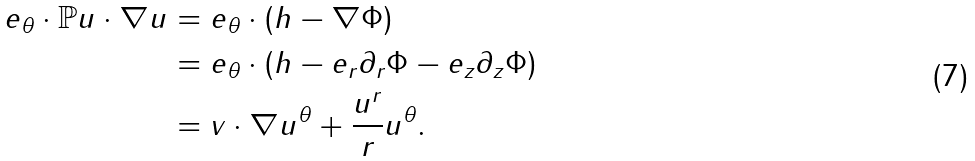<formula> <loc_0><loc_0><loc_500><loc_500>e _ { \theta } \cdot \mathbb { P } u \cdot \nabla u & = e _ { \theta } \cdot ( h - \nabla \Phi ) \\ & = e _ { \theta } \cdot ( h - e _ { r } \partial _ { r } \Phi - e _ { z } \partial _ { z } \Phi ) \\ & = v \cdot \nabla u ^ { \theta } + \frac { u ^ { r } } { r } u ^ { \theta } .</formula> 